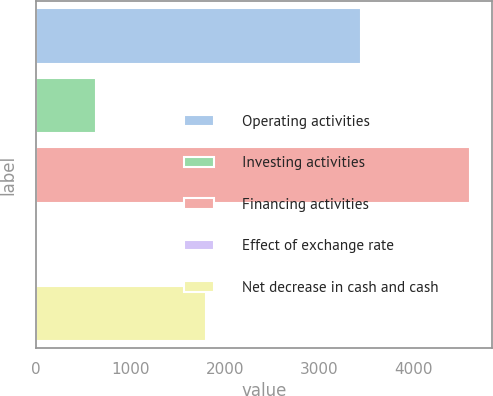<chart> <loc_0><loc_0><loc_500><loc_500><bar_chart><fcel>Operating activities<fcel>Investing activities<fcel>Financing activities<fcel>Effect of exchange rate<fcel>Net decrease in cash and cash<nl><fcel>3437<fcel>636<fcel>4595<fcel>3<fcel>1797<nl></chart> 